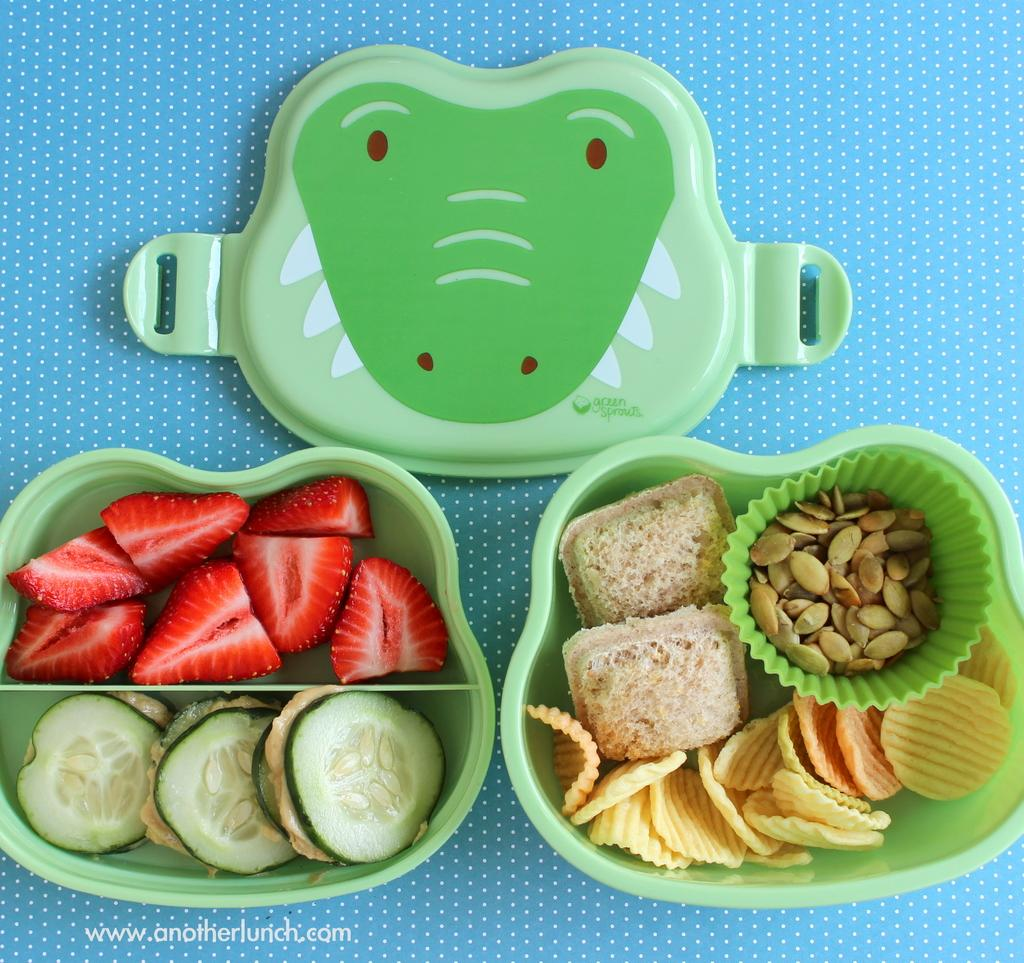What is the person holding in the image? The person is holding a camera and a tripod. What can be seen in the background of the image? There is a building in the background of the image. What type of hammer is being used to fix the building in the image? There is no hammer present in the image, and the building is not being fixed. --- Conversation: What is the person doing in the image? The person is sitting on a chair and reading a book. What is on the table next to the chair? There is a cup of coffee on the table. Reasoning: Let's think step by step in order to produce the conversation. We start by identifying the main subject in the image, which is the person sitting on a chair and reading a book. Then, we expand the conversation to include the table next to the chair, which has a cup of coffee on it. Each question is designed to elicit a specific detail about the image that is known from the provided facts. Absurd Question/Answer: What type of pickle is being used as a bookmark in the book? There is no pickle present in the image, and no pickle is being used as a bookmark. --- Conversation: What is the group of people doing in the image? The group of people is standing near a car. What color is the car? The car is red in color. Reasoning: Let's think step by step in order to produce the conversation. We start by identifying the main subject in the image, which is the group of people standing near a car. Then, we expand the conversation to include the color of the car, which is red. Each question is designed to elicit a specific detail about the image that is known from the provided facts. Absurd Question/Answer: What type of minister is standing next to the car in the image? There is no minister present in the image. --- Conversation: What is the cat doing in the image? The cat is sitting on a windowsill. What is next to the windowsill? The windowsill is next to a window. Reasoning: Let's think step by step in order to produce the conversation. We start by identifying the main subject in the image, which is the cat sitting on a windowsill. Then, we expand the conversation to include the location of the windowsill, which is next to a window. Each question is designed to elicit a specific detail about the image that is known from the provided facts. Absurd Question/Answer: What type of dog is being used as a doorstop in the image? There is no dog present in the image, and no dog is being used as a doorstop. --- Conversation: What is the dog doing in the image? The dog is playing with a ball. Q: 